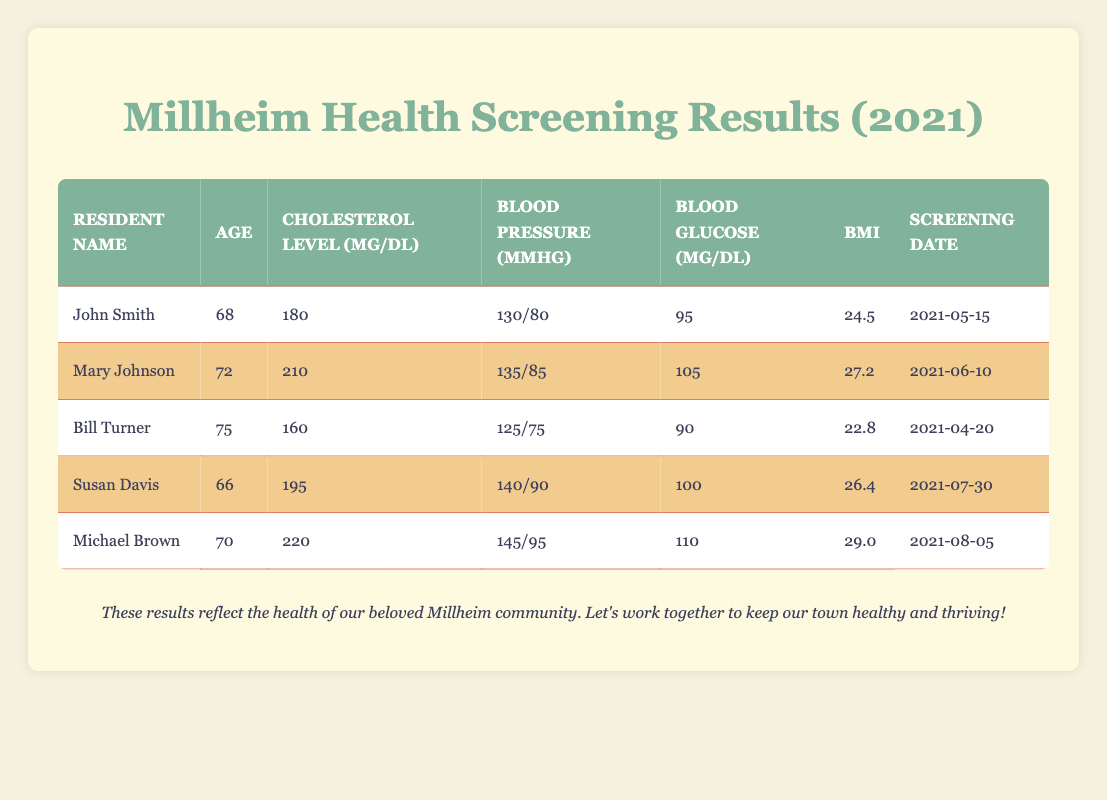What is the cholesterol level of Mary Johnson? Referring to the table, the row for Mary Johnson shows that her cholesterol level is 210 mg/dL.
Answer: 210 mg/dL Who has the highest blood pressure among the residents listed? By examining the blood pressure values, Michael Brown has the highest at 145/95 mmHg.
Answer: Michael Brown What is the average age of all residents screened? The ages are 68, 72, 75, 66, and 70. To find the average, sum these values: 68 + 72 + 75 + 66 + 70 = 351. There are 5 residents, so the average age is 351 / 5 = 70.2 years.
Answer: 70.2 years Is Susan Davis's BMI greater than 25? Looking at the BMI column, Susan Davis has a BMI of 26.4, which is greater than 25, therefore the answer is yes.
Answer: Yes What is the blood glucose level of the youngest resident? The youngest resident is Susan Davis at 66 years old. Her blood glucose level is 100 mg/dL, as noted in the table.
Answer: 100 mg/dL How many residents have a cholesterol level above 200 mg/dL? By checking the cholesterol levels: Mary Johnson (210 mg/dL) and Michael Brown (220 mg/dL) are above 200 mg/dL. Thus, there are 2 residents.
Answer: 2 What is the difference between the highest and lowest BMI among the residents? The highest BMI is Michael Brown with a BMI of 29.0 and the lowest is Bill Turner with a BMI of 22.8. The difference is 29.0 - 22.8 = 6.2.
Answer: 6.2 Is it true that all residents are over 65 years of age? All ages in the table are 66, 68, 70, 72, and 75, which are all over 65. Therefore, the answer is yes.
Answer: Yes What is the sum of cholesterol levels for residents above the age of 70? The residents above 70 are Mary Johnson (210 mg/dL), Bill Turner (160 mg/dL), and Michael Brown (220 mg/dL). The sum is 210 + 220 = 430 mg/dL.
Answer: 430 mg/dL 